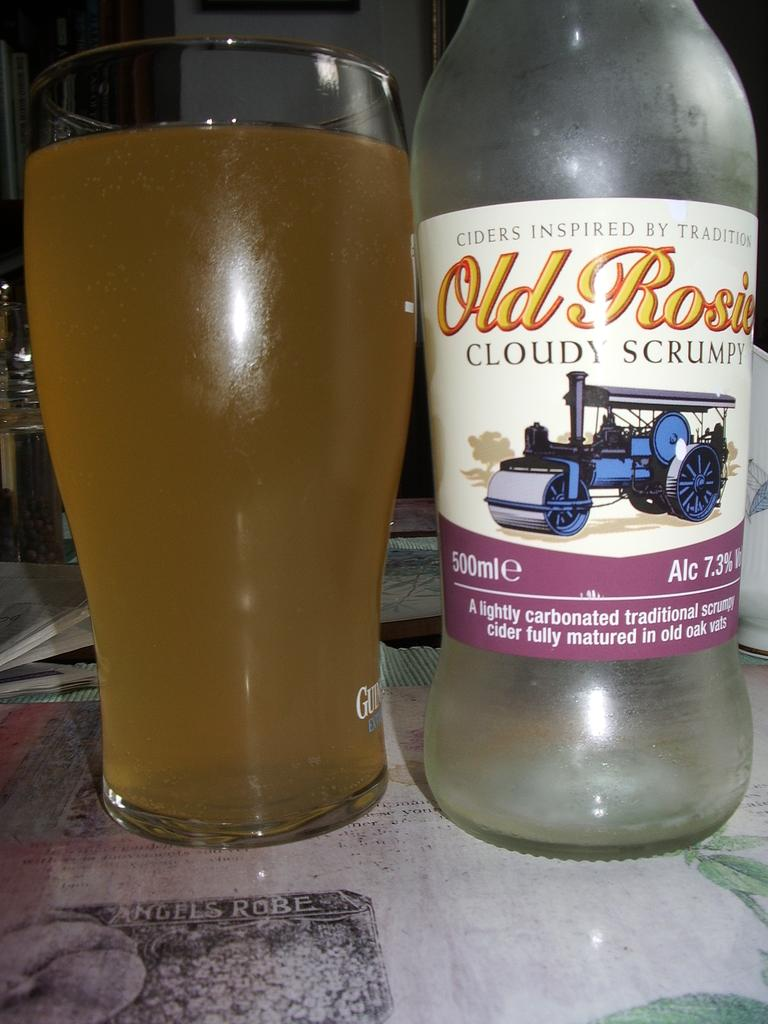What can be seen in the image that is used for holding liquids? There is a bottle in the image. What is written on the label of the bottle? The label on the bottle says "Old Rosie Cloudy Scrumpy." What is the glass in the image being used for? The glass in the image is being used for holding a drink. Can you tell me how many pumpkins are on the guitar in the image? There is no guitar or pumpkins present in the image. 